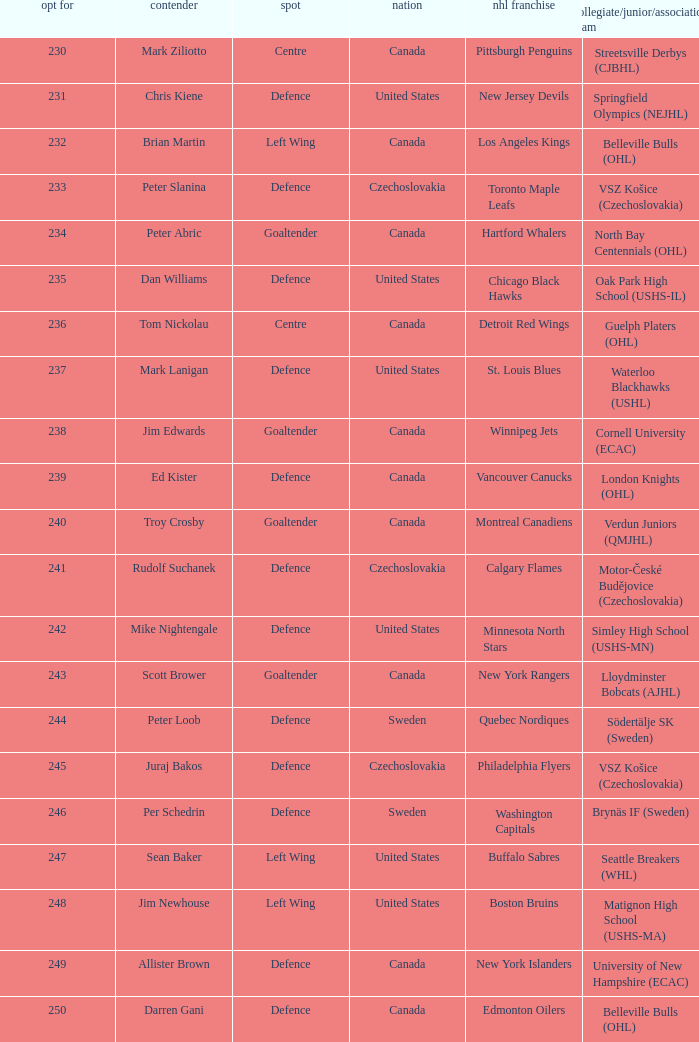What selection was the springfield olympics (nejhl)? 231.0. 